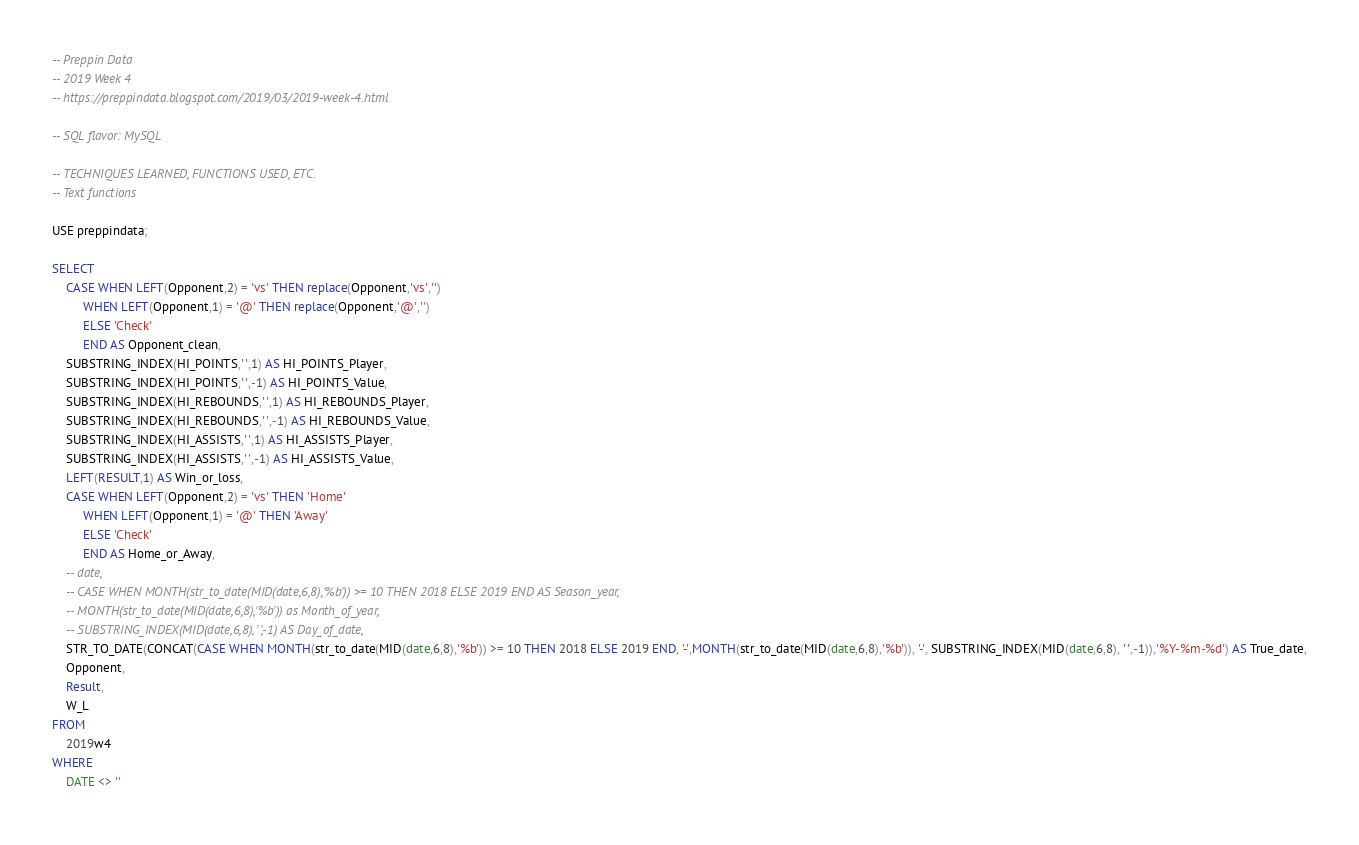<code> <loc_0><loc_0><loc_500><loc_500><_SQL_>-- Preppin Data
-- 2019 Week 4
-- https://preppindata.blogspot.com/2019/03/2019-week-4.html

-- SQL flavor: MySQL

-- TECHNIQUES LEARNED, FUNCTIONS USED, ETC.
-- Text functions

USE preppindata;

SELECT 
	CASE WHEN LEFT(Opponent,2) = 'vs' THEN replace(Opponent,'vs','') 
		 WHEN LEFT(Opponent,1) = '@' THEN replace(Opponent,'@','')
         ELSE 'Check'
         END AS Opponent_clean,         
    SUBSTRING_INDEX(HI_POINTS,' ',1) AS HI_POINTS_Player,
    SUBSTRING_INDEX(HI_POINTS,' ',-1) AS HI_POINTS_Value,
    SUBSTRING_INDEX(HI_REBOUNDS,' ',1) AS HI_REBOUNDS_Player,
    SUBSTRING_INDEX(HI_REBOUNDS,' ',-1) AS HI_REBOUNDS_Value,
    SUBSTRING_INDEX(HI_ASSISTS,' ',1) AS HI_ASSISTS_Player,
    SUBSTRING_INDEX(HI_ASSISTS,' ',-1) AS HI_ASSISTS_Value,
    LEFT(RESULT,1) AS Win_or_loss,
    CASE WHEN LEFT(Opponent,2) = 'vs' THEN 'Home' 
		 WHEN LEFT(Opponent,1) = '@' THEN 'Away'
         ELSE 'Check'
         END AS Home_or_Away,
	-- date,
    -- CASE WHEN MONTH(str_to_date(MID(date,6,8),'%b')) >= 10 THEN 2018 ELSE 2019 END AS Season_year,
    -- MONTH(str_to_date(MID(date,6,8),'%b')) as Month_of_year,
	-- SUBSTRING_INDEX(MID(date,6,8), ' ',-1) AS Day_of_date,
    STR_TO_DATE(CONCAT(CASE WHEN MONTH(str_to_date(MID(date,6,8),'%b')) >= 10 THEN 2018 ELSE 2019 END, '-',MONTH(str_to_date(MID(date,6,8),'%b')), '-', SUBSTRING_INDEX(MID(date,6,8), ' ',-1)),'%Y-%m-%d') AS True_date,
    Opponent,
    Result,
    W_L
FROM
    2019w4
WHERE
    DATE <> ''</code> 